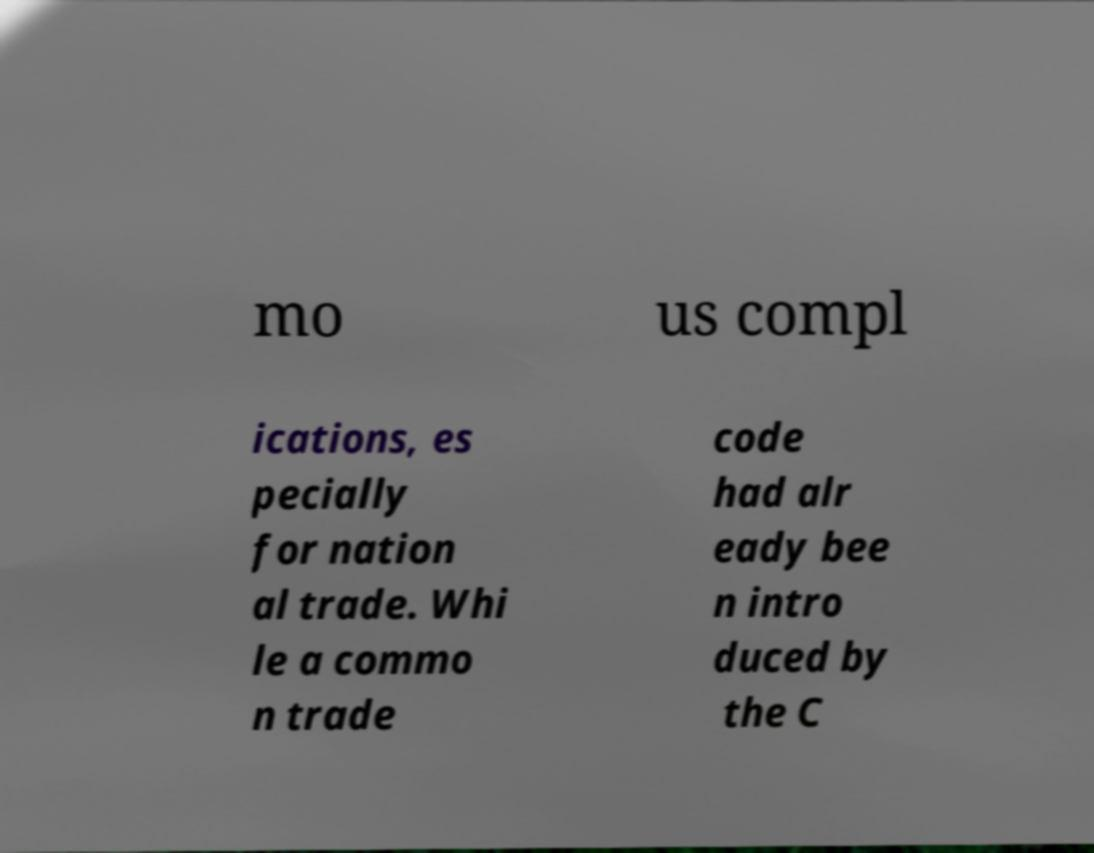For documentation purposes, I need the text within this image transcribed. Could you provide that? mo us compl ications, es pecially for nation al trade. Whi le a commo n trade code had alr eady bee n intro duced by the C 